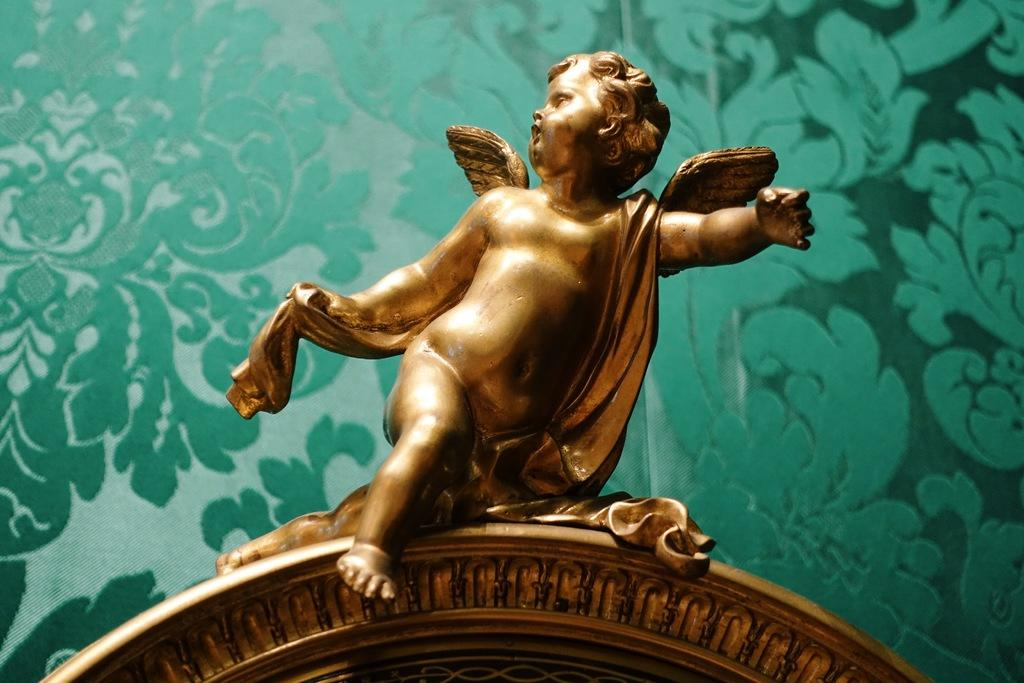What is the subject of the statue in the image? The statue is of a child. What distinguishing feature does the child have? The child has wings. What is the statue made of? The statue is made of a gold color material. What type of car is parked next to the statue in the image? There is no car present in the image; it only features a statue of a child with wings made of a gold color material. What is the title of the statue in the image? There is: There is no title provided for the statue in the image. 